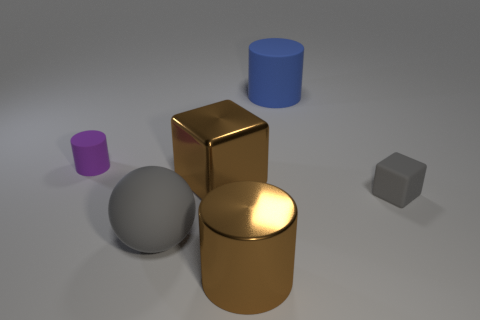Is there anything else that is the same shape as the big gray object?
Provide a succinct answer. No. There is a cylinder that is in front of the purple matte cylinder; does it have the same size as the blue thing?
Ensure brevity in your answer.  Yes. What number of blue cylinders are on the right side of the small gray rubber cube?
Make the answer very short. 0. Are there any purple matte cylinders that have the same size as the matte block?
Your answer should be compact. Yes. Does the shiny cube have the same color as the metallic cylinder?
Provide a short and direct response. Yes. What is the color of the tiny rubber cube that is in front of the thing behind the purple rubber thing?
Your answer should be very brief. Gray. What number of large things are right of the brown cube and in front of the small gray object?
Your answer should be compact. 1. What number of small rubber objects have the same shape as the big blue object?
Your response must be concise. 1. Does the large cube have the same material as the small gray thing?
Provide a succinct answer. No. The small object that is in front of the tiny object left of the gray cube is what shape?
Your response must be concise. Cube. 